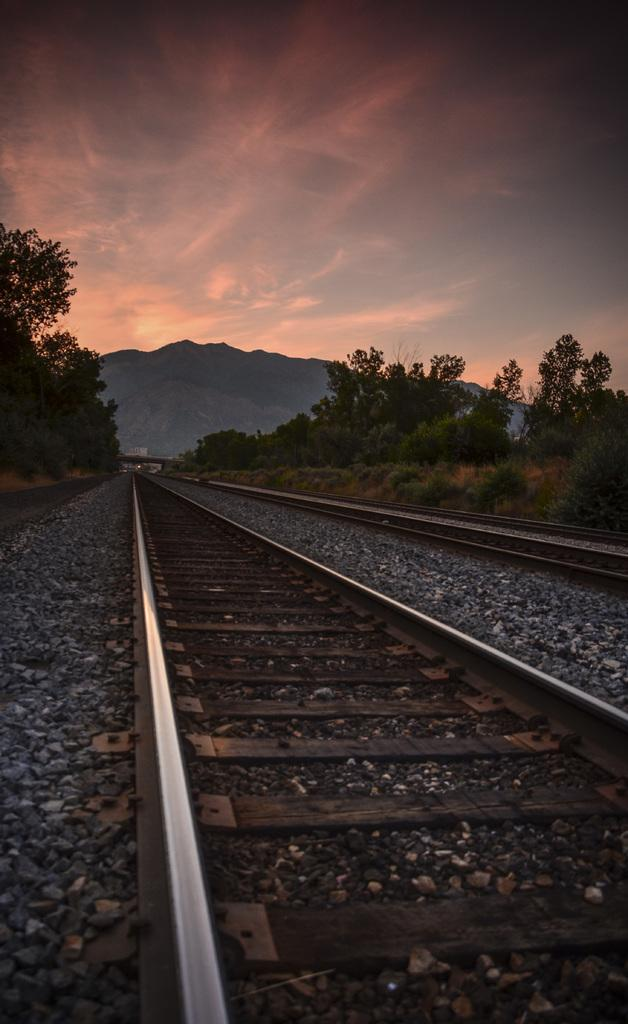What type of transportation infrastructure is present in the image? There are railway tracks in the image. What other natural elements can be seen in the image? There are stones, trees, and a hill visible in the image. What is visible in the background of the image? The sky is visible in the image. What type of crayon is being used to color the servant in the image? There is no servant or crayon present in the image. 